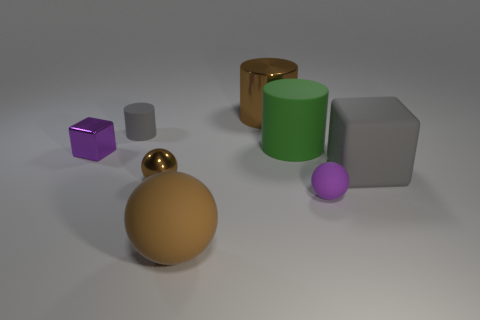Is the color of the metal cylinder the same as the small metal thing that is to the right of the purple block?
Your answer should be very brief. Yes. How many objects are gray cylinders or metallic things right of the tiny cylinder?
Your answer should be very brief. 3. There is a large object on the right side of the small purple object that is to the right of the tiny sphere to the left of the large sphere; what is it made of?
Your response must be concise. Rubber. What is the size of the cylinder that is made of the same material as the tiny gray object?
Keep it short and to the point. Large. The cylinder that is on the right side of the brown thing behind the purple metallic object is what color?
Your answer should be very brief. Green. How many small gray cylinders are the same material as the big sphere?
Your answer should be very brief. 1. How many metal objects are tiny blue balls or tiny cylinders?
Your response must be concise. 0. There is a brown thing that is the same size as the brown rubber ball; what is its material?
Give a very brief answer. Metal. Is there a brown sphere that has the same material as the brown cylinder?
Offer a very short reply. Yes. There is a small metal thing in front of the gray rubber object that is on the right side of the tiny rubber cylinder that is behind the green rubber cylinder; what is its shape?
Your response must be concise. Sphere. 